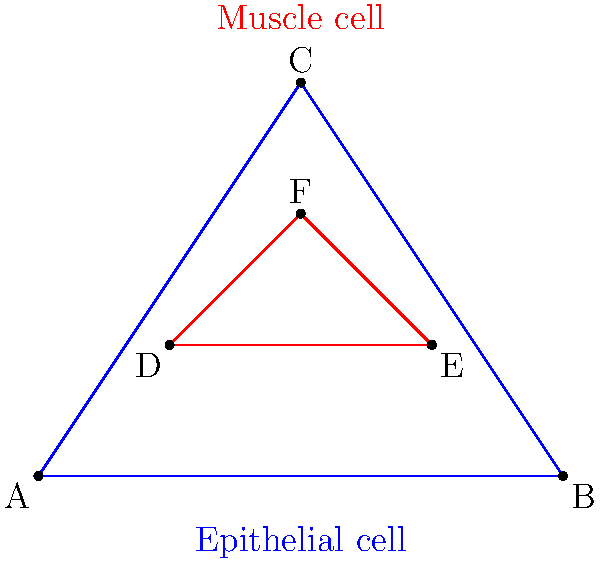In a study comparing cell structures across different human tissues, you observe that epithelial cells and muscle cells have similar triangular shapes. The epithelial cell is represented by triangle ABC, and the muscle cell by triangle DEF. If $\overline{AB} = 4$ µm, $\overline{BC} = \sqrt{13}$ µm, $\overline{AC} = \sqrt{13}$ µm, $\overline{DE} = 2$ µm, and $\angle BAC = \angle EDF = 90°$, determine if these cell structures are congruent. If they are, state which congruence criterion applies. Let's approach this step-by-step:

1) First, we need to check if the triangles have the same shape and size to be congruent.

2) We're given that $\angle BAC = \angle EDF = 90°$, so both triangles have a right angle.

3) For triangle ABC:
   - $\overline{AB} = 4$ µm
   - $\overline{BC} = \sqrt{13}$ µm
   - $\overline{AC} = \sqrt{13}$ µm

4) For triangle DEF:
   - $\overline{DE} = 2$ µm
   - We need to find $\overline{EF}$ and $\overline{DF}$

5) Notice that triangle ABC is a right-angled triangle where the two non-hypotenuse sides are equal. This makes it a 45-45-90 triangle, where the ratio of sides is 1 : 1 : $\sqrt{2}$.

6) In triangle ABC, the shortest side (AB) is 4 µm, and the other two sides are $\sqrt{13}$ µm, which is indeed $4\sqrt{2}$ µm.

7) For triangle DEF to be congruent, it should have the same ratio but half the size (since DE is half of AB):
   - $\overline{DE} = 2$ µm
   - $\overline{EF} = \overline{DF} = 2\sqrt{2}$ µm

8) To confirm, we can calculate:
   $2\sqrt{2} = 2 * 1.414 \approx 2.828$ µm

9) The triangles are indeed congruent, as all corresponding sides are in proportion and they share a congruent angle (the right angle).

10) The congruence criterion that applies here is the SAS (Side-Angle-Side) criterion. We have:
    - A pair of congruent sides: $\overline{AB} = 2\overline{DE}$
    - A congruent included angle: $\angle BAC = \angle EDF = 90°$
    - Another pair of congruent sides: $\overline{AC} = 2\overline{DF}$
Answer: Yes, congruent; SAS criterion 